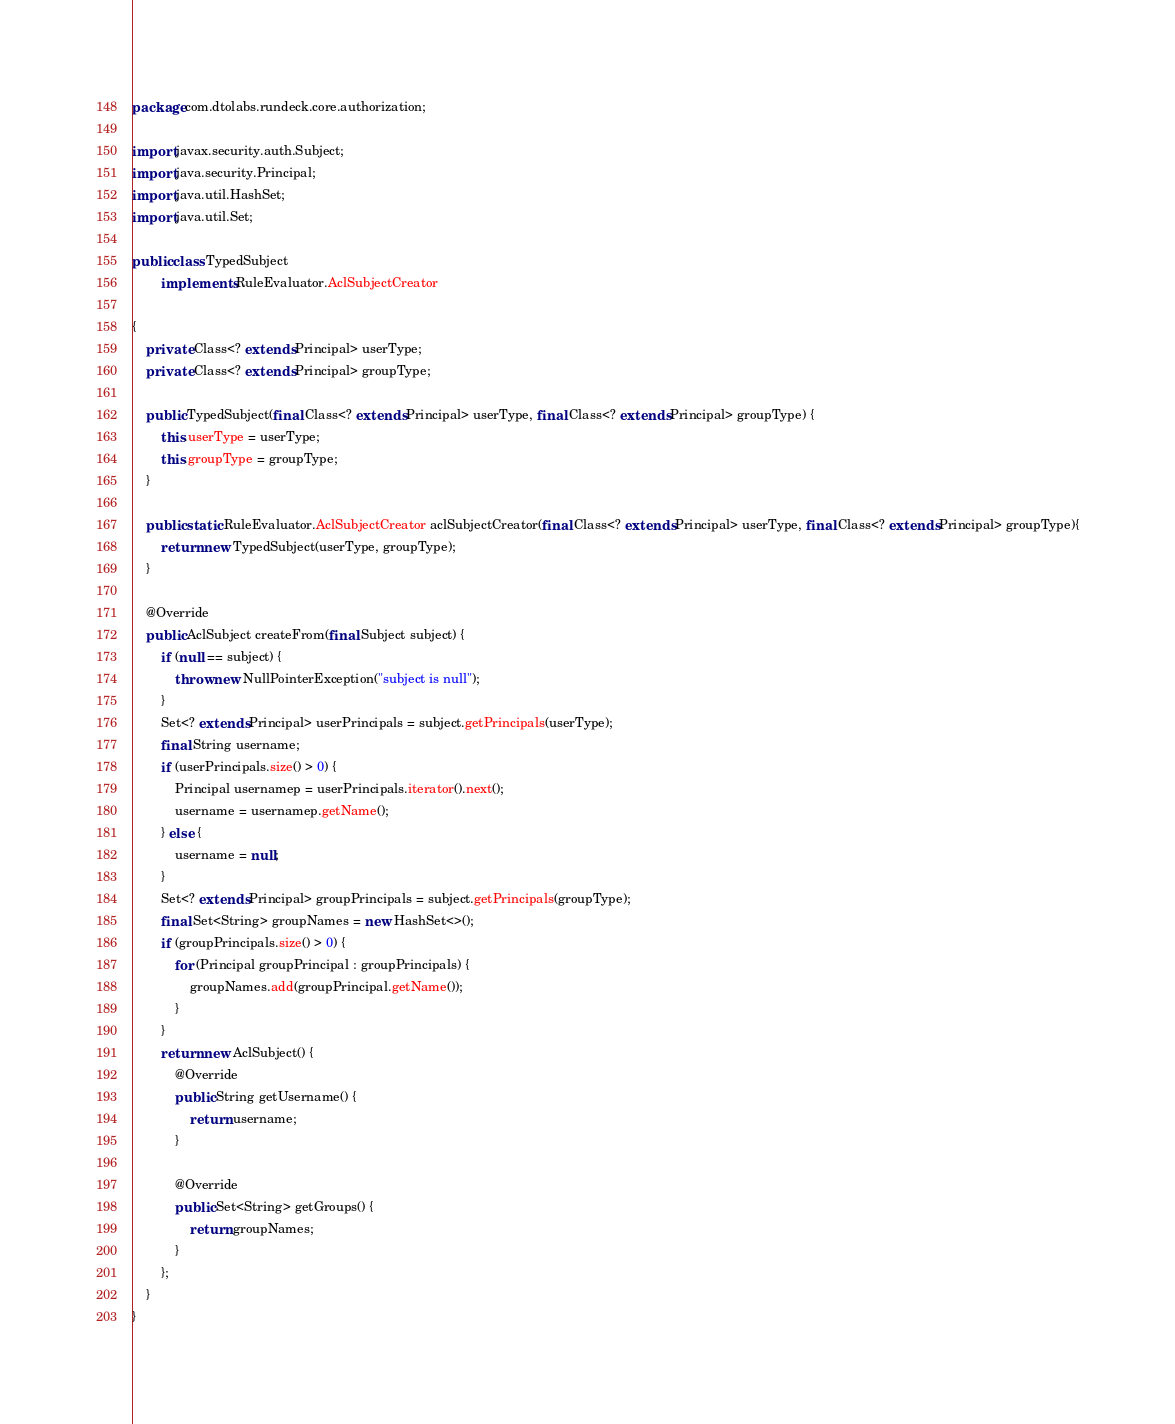Convert code to text. <code><loc_0><loc_0><loc_500><loc_500><_Java_>package com.dtolabs.rundeck.core.authorization;

import javax.security.auth.Subject;
import java.security.Principal;
import java.util.HashSet;
import java.util.Set;

public class TypedSubject
        implements RuleEvaluator.AclSubjectCreator

{
    private Class<? extends Principal> userType;
    private Class<? extends Principal> groupType;

    public TypedSubject(final Class<? extends Principal> userType, final Class<? extends Principal> groupType) {
        this.userType = userType;
        this.groupType = groupType;
    }

    public static RuleEvaluator.AclSubjectCreator aclSubjectCreator(final Class<? extends Principal> userType, final Class<? extends Principal> groupType){
        return new TypedSubject(userType, groupType);
    }

    @Override
    public AclSubject createFrom(final Subject subject) {
        if (null == subject) {
            throw new NullPointerException("subject is null");
        }
        Set<? extends Principal> userPrincipals = subject.getPrincipals(userType);
        final String username;
        if (userPrincipals.size() > 0) {
            Principal usernamep = userPrincipals.iterator().next();
            username = usernamep.getName();
        } else {
            username = null;
        }
        Set<? extends Principal> groupPrincipals = subject.getPrincipals(groupType);
        final Set<String> groupNames = new HashSet<>();
        if (groupPrincipals.size() > 0) {
            for (Principal groupPrincipal : groupPrincipals) {
                groupNames.add(groupPrincipal.getName());
            }
        }
        return new AclSubject() {
            @Override
            public String getUsername() {
                return username;
            }

            @Override
            public Set<String> getGroups() {
                return groupNames;
            }
        };
    }
}
</code> 